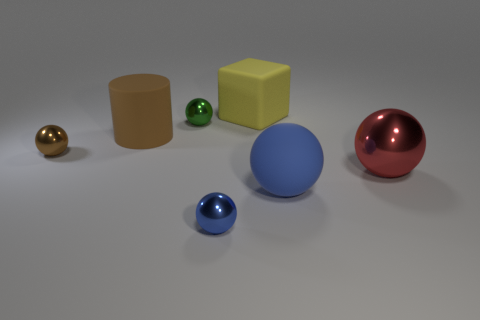Is there a large gray ball made of the same material as the big brown cylinder? While there is no large gray ball present, there is a large blue spherical object and a brown cylindrical object in the picture. The materials of the two objects appear different; the cylinder has a matte finish typical of a diffuse material, whereas the sphere has a shinier surface suggesting a different material with more specular reflection. 